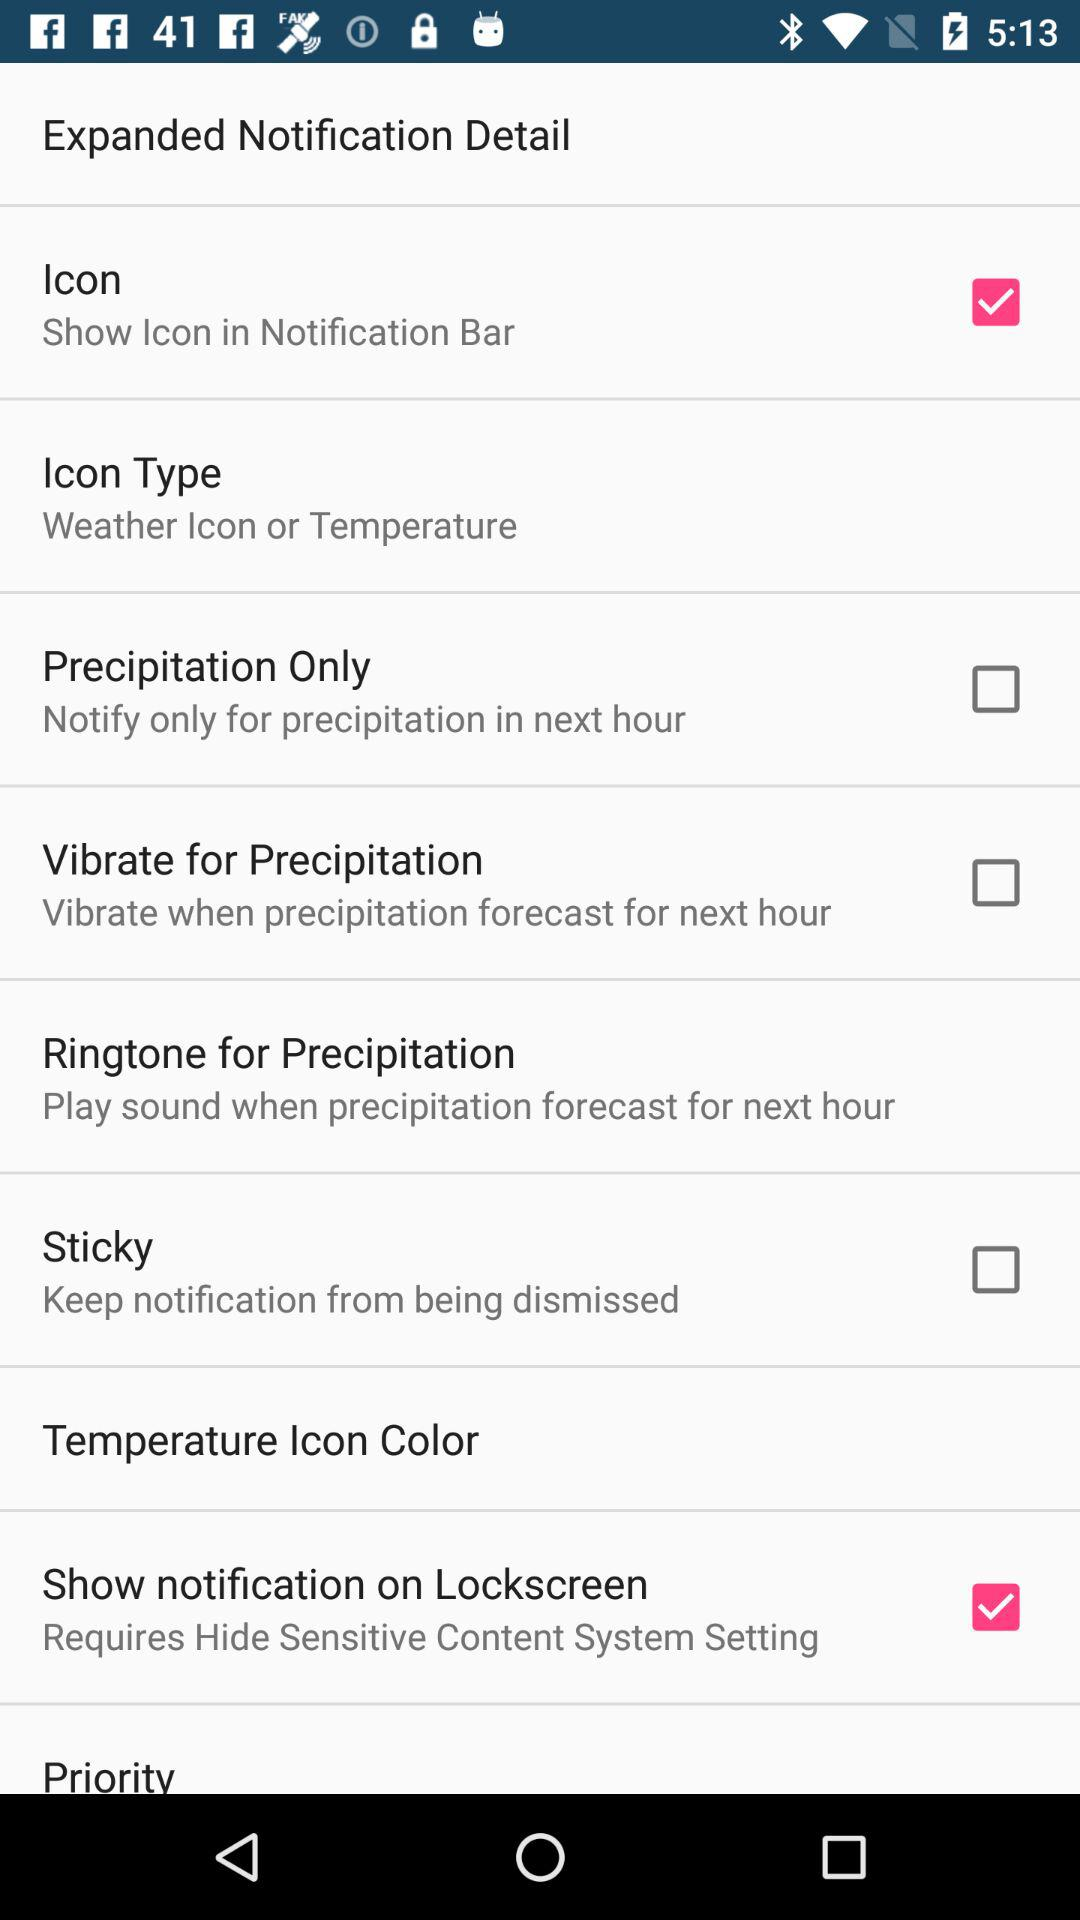An icon is shown in which bar? An icon is shown in the notification bar. 